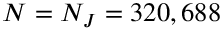<formula> <loc_0><loc_0><loc_500><loc_500>N = N _ { J } = 3 2 0 , 6 8 8</formula> 